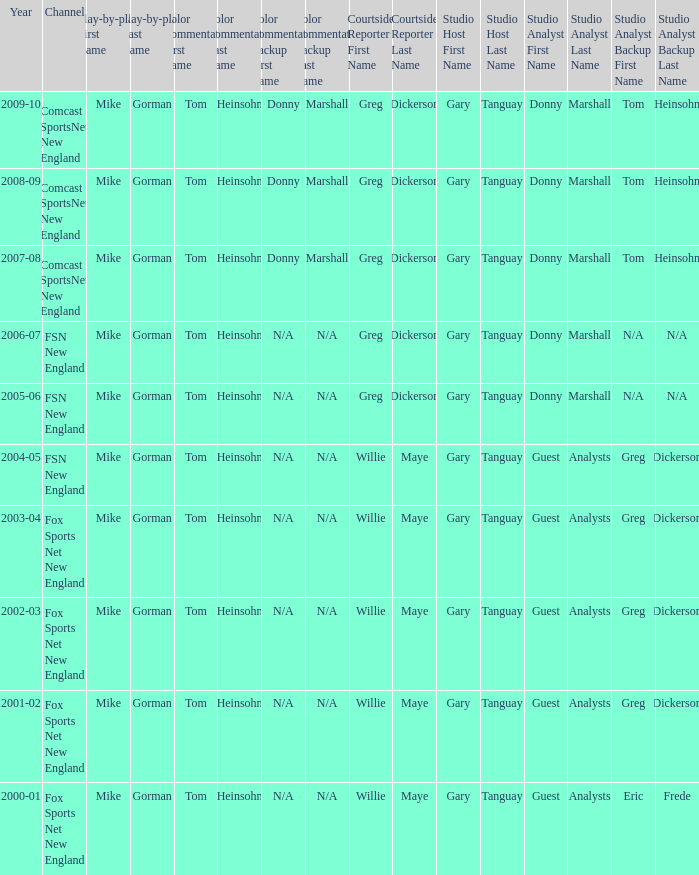WHich Studio host has a Year of 2003-04? Gary Tanguay & Greg Dickerson. 